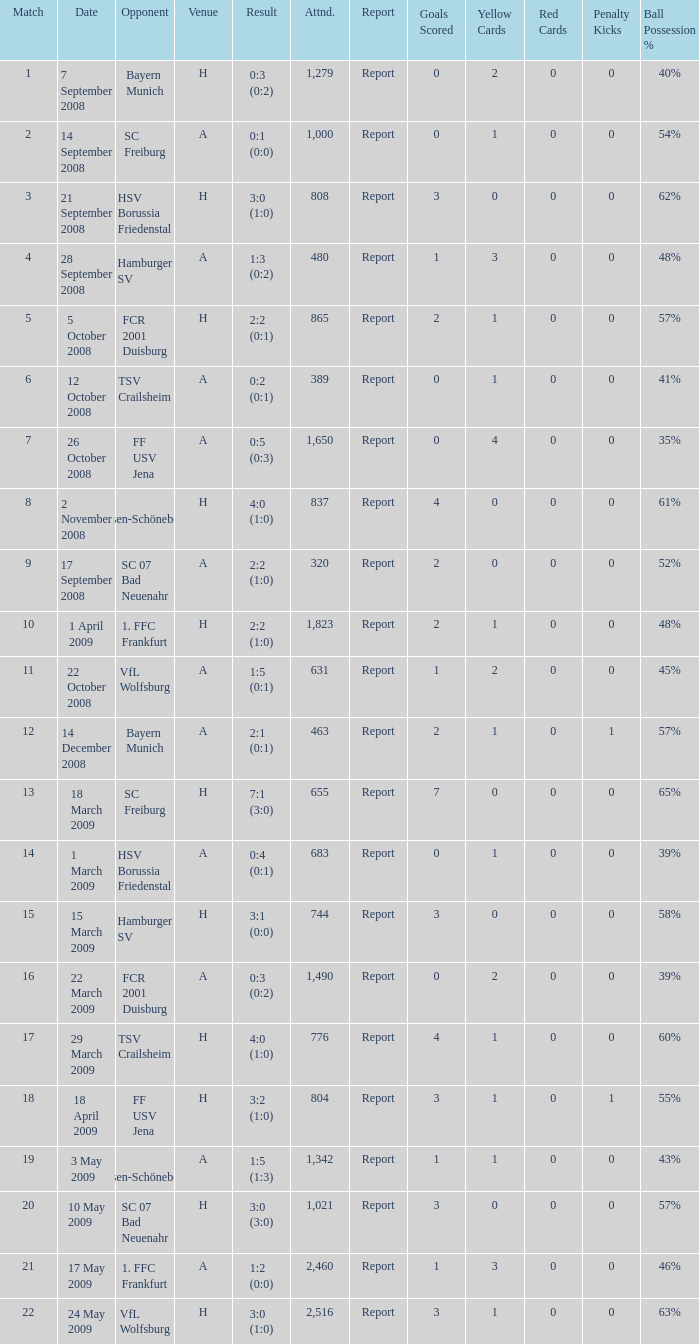Which match did FCR 2001 Duisburg participate as the opponent? 21.0. Would you mind parsing the complete table? {'header': ['Match', 'Date', 'Opponent', 'Venue', 'Result', 'Attnd.', 'Report', 'Goals Scored', 'Yellow Cards', 'Red Cards', 'Penalty Kicks', 'Ball Possession %'], 'rows': [['1', '7 September 2008', 'Bayern Munich', 'H', '0:3 (0:2)', '1,279', 'Report', '0', '2', '0', '0', '40%'], ['2', '14 September 2008', 'SC Freiburg', 'A', '0:1 (0:0)', '1,000', 'Report', '0', '1', '0', '0', '54%'], ['3', '21 September 2008', 'HSV Borussia Friedenstal', 'H', '3:0 (1:0)', '808', 'Report', '3', '0', '0', '0', '62%'], ['4', '28 September 2008', 'Hamburger SV', 'A', '1:3 (0:2)', '480', 'Report', '1', '3', '0', '0', '48%'], ['5', '5 October 2008', 'FCR 2001 Duisburg', 'H', '2:2 (0:1)', '865', 'Report', '2', '1', '0', '0', '57%'], ['6', '12 October 2008', 'TSV Crailsheim', 'A', '0:2 (0:1)', '389', 'Report', '0', '1', '0', '0', '41%'], ['7', '26 October 2008', 'FF USV Jena', 'A', '0:5 (0:3)', '1,650', 'Report', '0', '4', '0', '0', '35%'], ['8', '2 November 2008', 'SG Essen-Schönebeck', 'H', '4:0 (1:0)', '837', 'Report', '4', '0', '0', '0', '61%'], ['9', '17 September 2008', 'SC 07 Bad Neuenahr', 'A', '2:2 (1:0)', '320', 'Report', '2', '0', '0', '0', '52%'], ['10', '1 April 2009', '1. FFC Frankfurt', 'H', '2:2 (1:0)', '1,823', 'Report', '2', '1', '0', '0', '48%'], ['11', '22 October 2008', 'VfL Wolfsburg', 'A', '1:5 (0:1)', '631', 'Report', '1', '2', '0', '0', '45%'], ['12', '14 December 2008', 'Bayern Munich', 'A', '2:1 (0:1)', '463', 'Report', '2', '1', '0', '1', '57%'], ['13', '18 March 2009', 'SC Freiburg', 'H', '7:1 (3:0)', '655', 'Report', '7', '0', '0', '0', '65%'], ['14', '1 March 2009', 'HSV Borussia Friedenstal', 'A', '0:4 (0:1)', '683', 'Report', '0', '1', '0', '0', '39%'], ['15', '15 March 2009', 'Hamburger SV', 'H', '3:1 (0:0)', '744', 'Report', '3', '0', '0', '0', '58%'], ['16', '22 March 2009', 'FCR 2001 Duisburg', 'A', '0:3 (0:2)', '1,490', 'Report', '0', '2', '0', '0', '39%'], ['17', '29 March 2009', 'TSV Crailsheim', 'H', '4:0 (1:0)', '776', 'Report', '4', '1', '0', '0', '60%'], ['18', '18 April 2009', 'FF USV Jena', 'H', '3:2 (1:0)', '804', 'Report', '3', '1', '0', '1', '55%'], ['19', '3 May 2009', 'SG Essen-Schönebeck', 'A', '1:5 (1:3)', '1,342', 'Report', '1', '1', '0', '0', '43%'], ['20', '10 May 2009', 'SC 07 Bad Neuenahr', 'H', '3:0 (3:0)', '1,021', 'Report', '3', '0', '0', '0', '57%'], ['21', '17 May 2009', '1. FFC Frankfurt', 'A', '1:2 (0:0)', '2,460', 'Report', '1', '3', '0', '0', '46%'], ['22', '24 May 2009', 'VfL Wolfsburg', 'H', '3:0 (1:0)', '2,516', 'Report', '3', '1', '0', '0', '63%']]} 